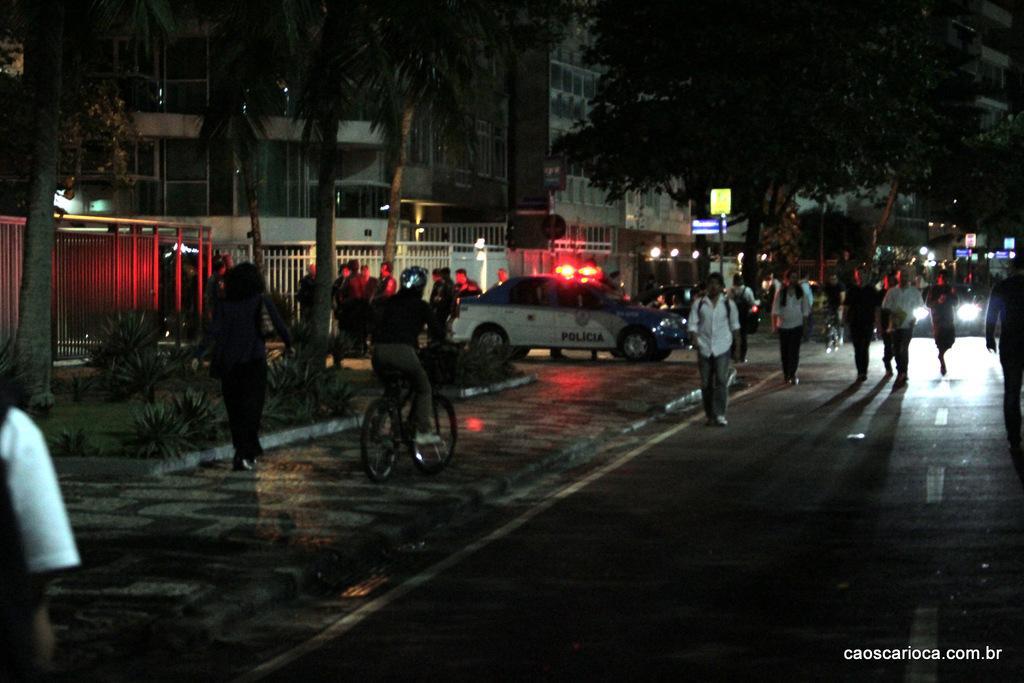Please provide a concise description of this image. In this picture I can see there are few people walking on the walk way and there is a person riding the bicycle and there is a car parked here and there are a group of people standing here. On the right there is a road and there are few people walking and there is a vehicle moving on the road and there are trees, plants. 